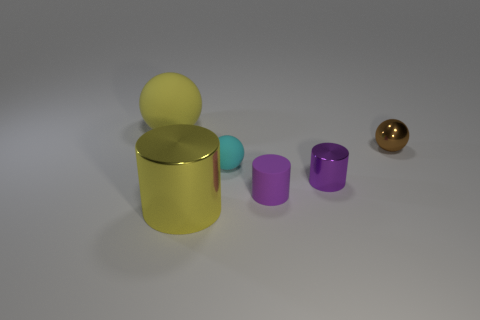Add 2 small purple metallic cylinders. How many objects exist? 8 Add 6 purple rubber objects. How many purple rubber objects are left? 7 Add 5 matte objects. How many matte objects exist? 8 Subtract 0 cyan cylinders. How many objects are left? 6 Subtract all yellow shiny cylinders. Subtract all tiny purple rubber things. How many objects are left? 4 